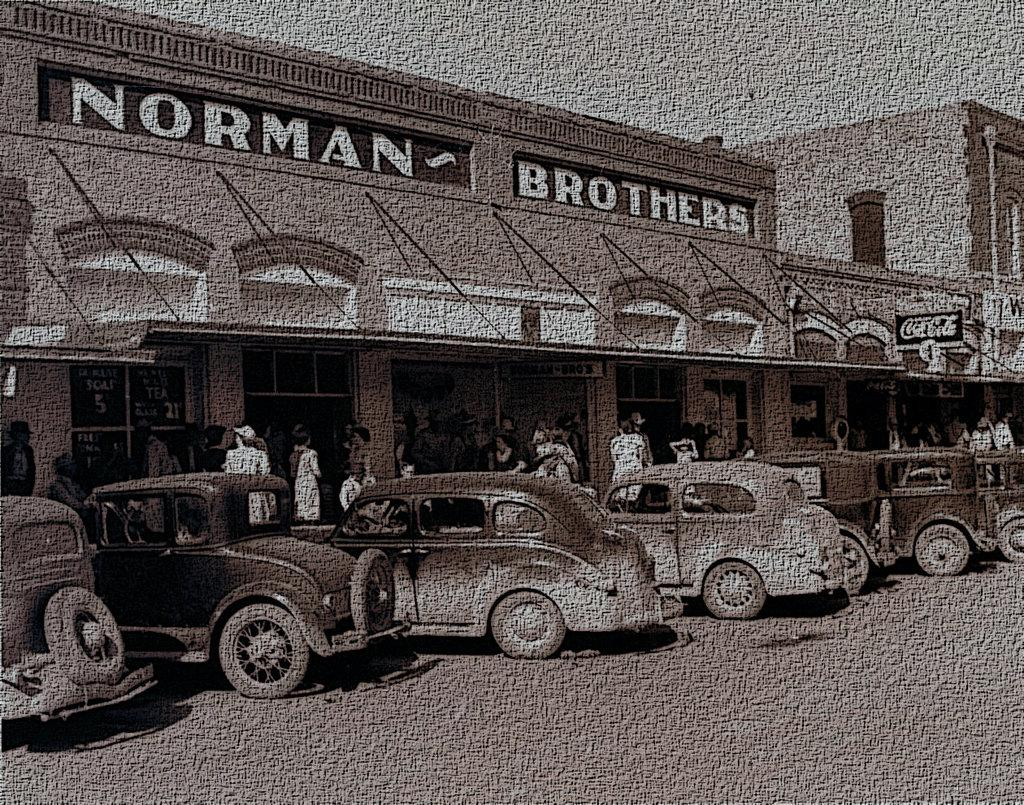What is the main subject of the photo in the image? The main subject of the photo in the image is buildings. What else can be seen in the photo besides buildings? The photo contains vehicles and people. What is the color scheme of the photo? The photo is black and white in color. Can you describe any other unspecified things in the photo? Unfortunately, the provided facts do not specify any other details about the unspecified things in the photo. What type of sheet is covering the minister in the image? There is no minister or sheet present in the image; it contains a photo of buildings, vehicles, and people. 